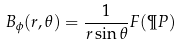<formula> <loc_0><loc_0><loc_500><loc_500>B _ { \phi } ( r , \theta ) = \frac { 1 } { r \sin \theta } F ( \P P )</formula> 